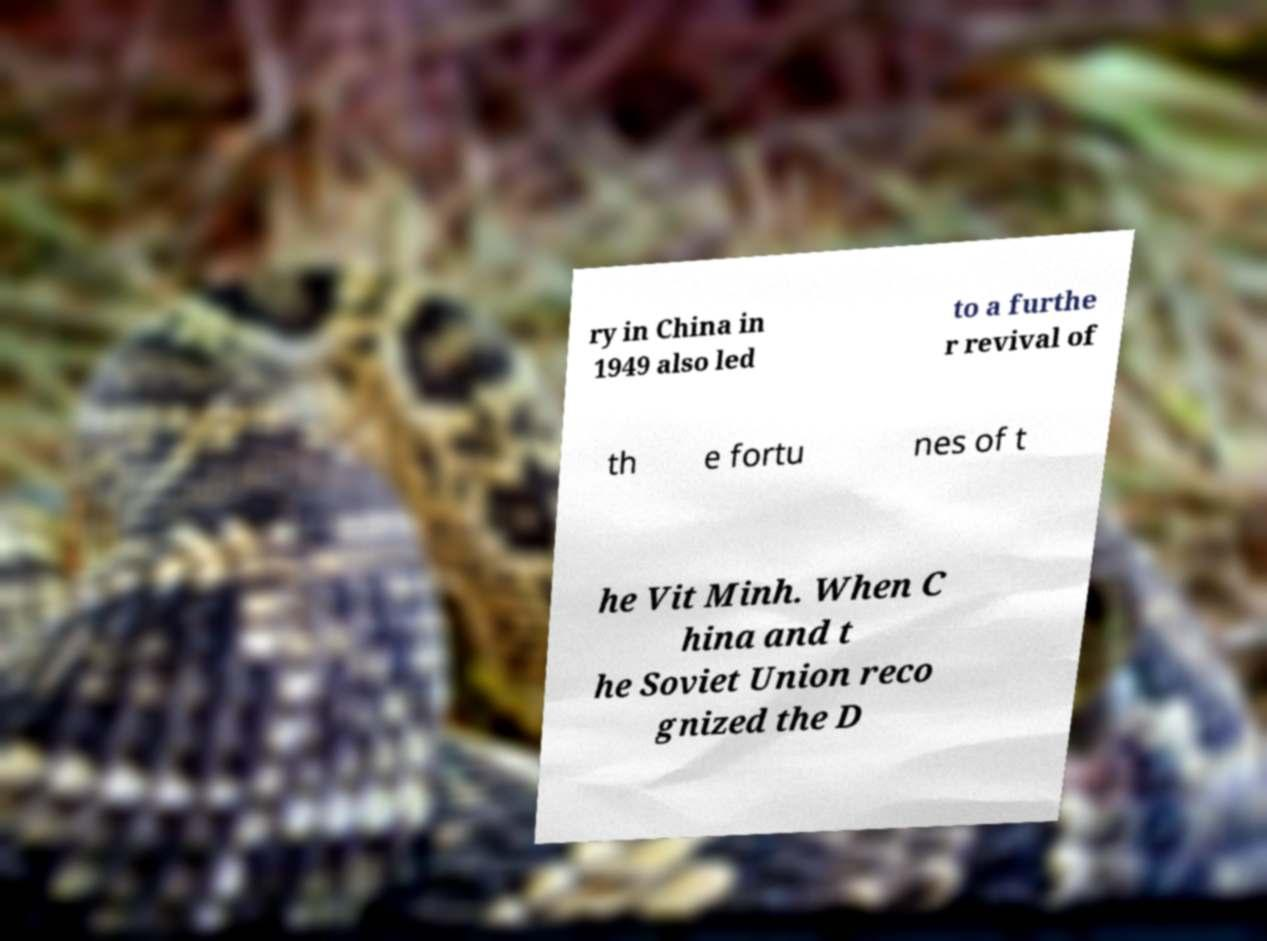Please read and relay the text visible in this image. What does it say? ry in China in 1949 also led to a furthe r revival of th e fortu nes of t he Vit Minh. When C hina and t he Soviet Union reco gnized the D 